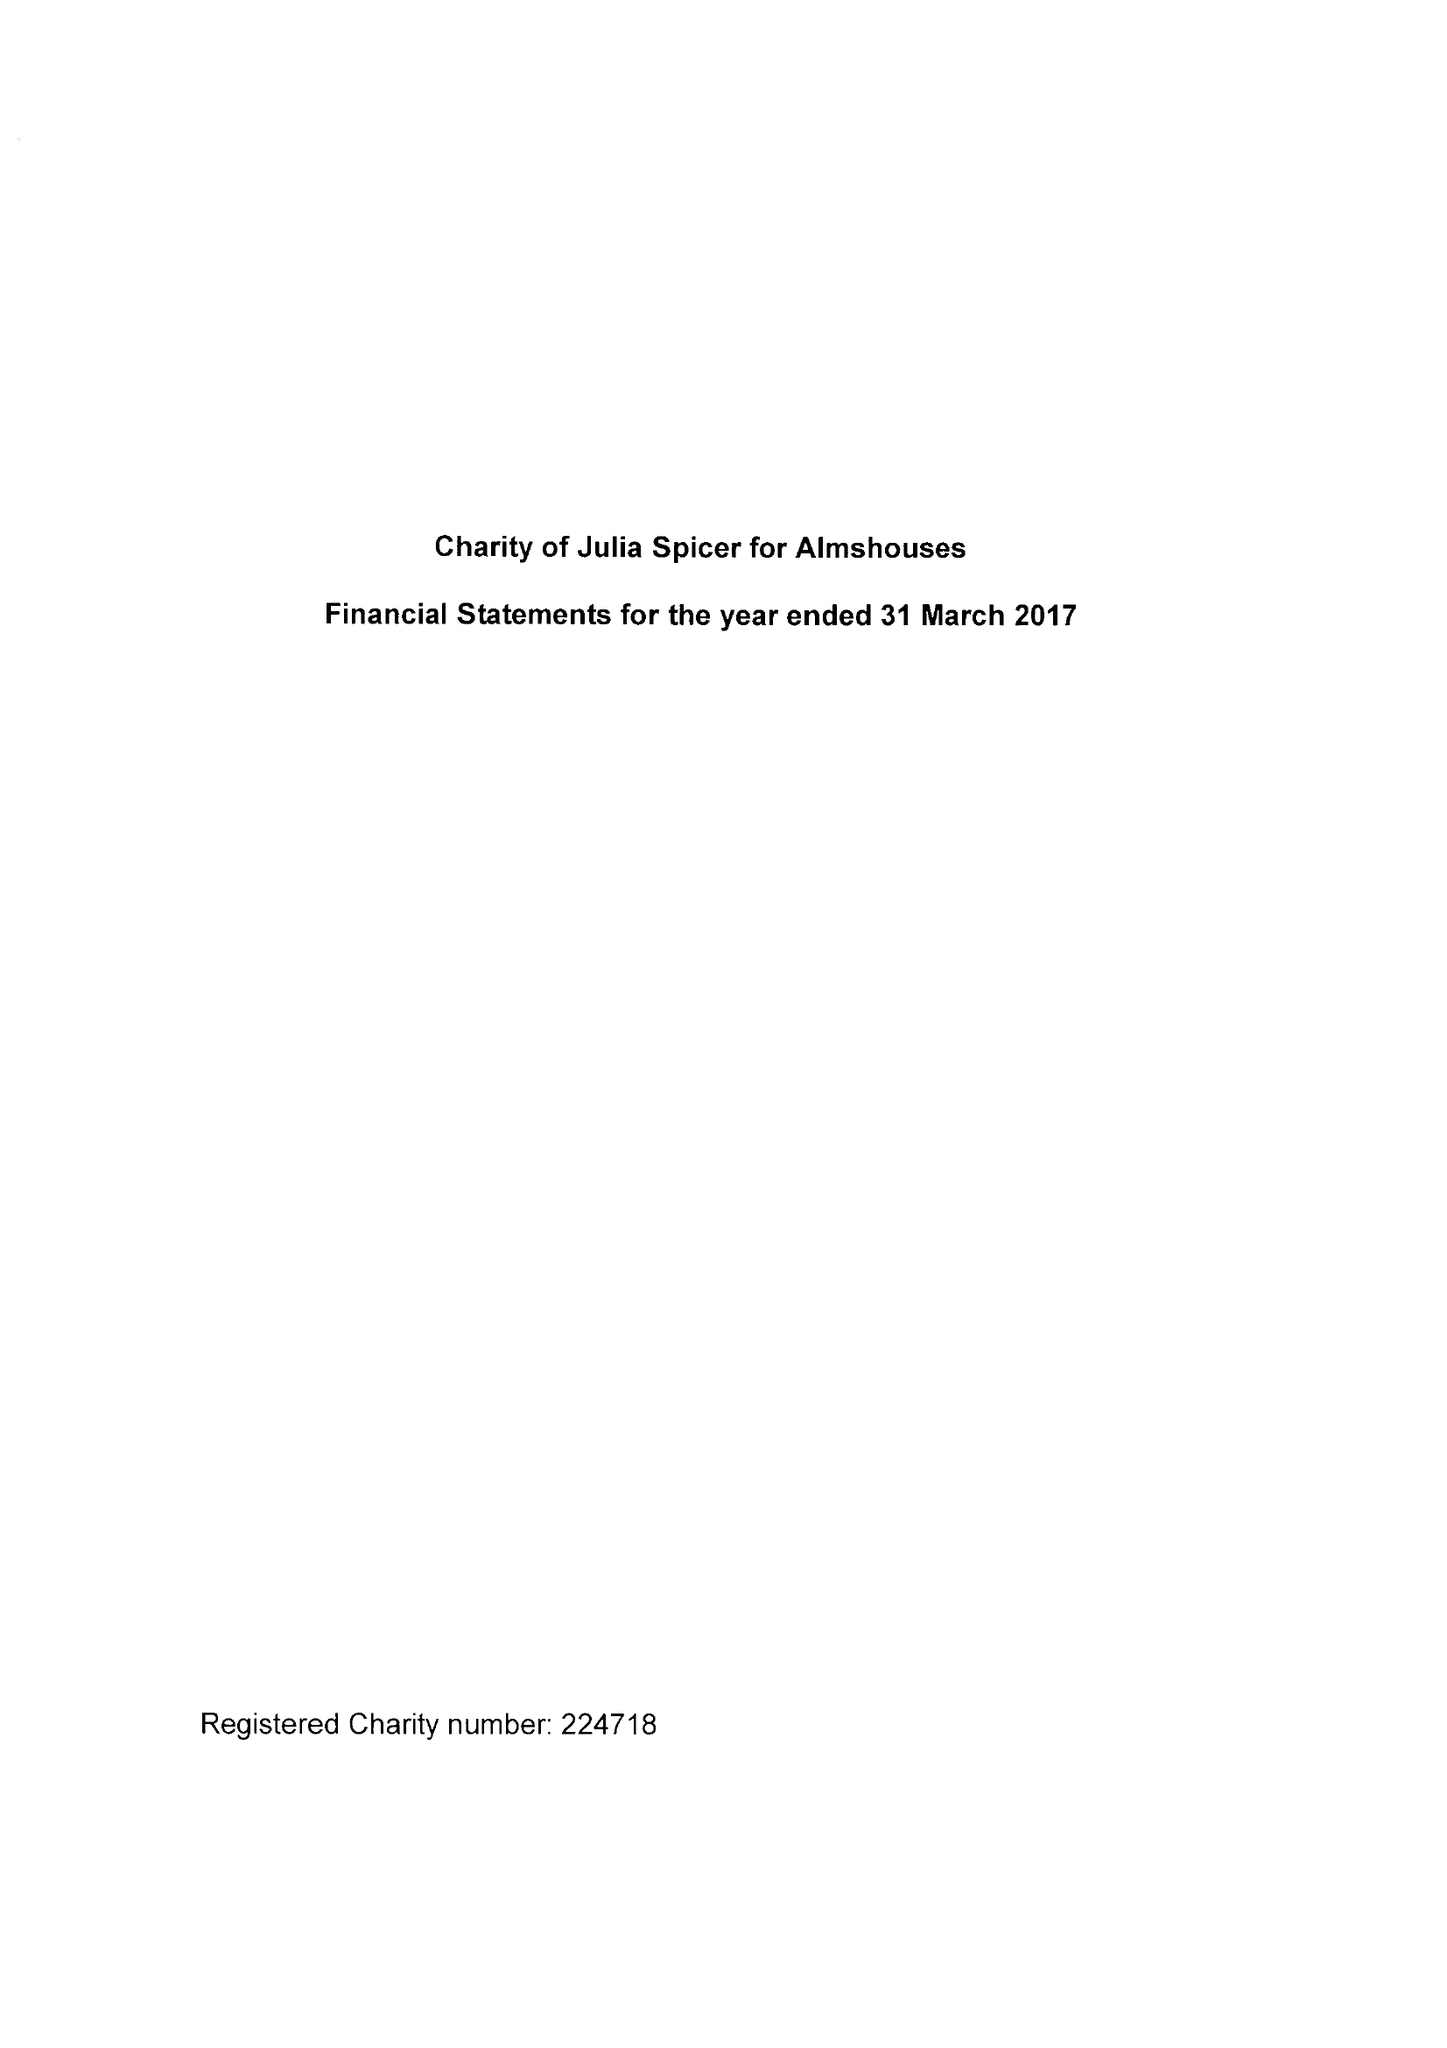What is the value for the address__postcode?
Answer the question using a single word or phrase. CR0 9XP 